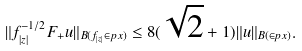<formula> <loc_0><loc_0><loc_500><loc_500>\| f _ { | z | } ^ { - 1 / 2 } F _ { + } u \| _ { B ( f _ { | z | } \in p { x } ) } \leq 8 ( \sqrt { 2 } + 1 ) \| u \| _ { B ( \in p { x } ) } .</formula> 